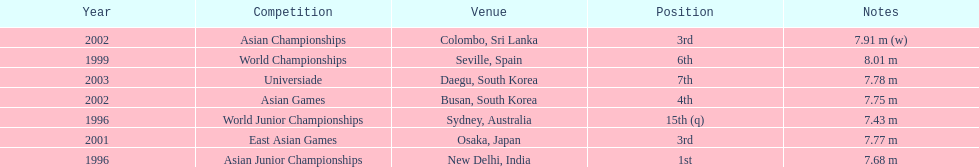In what year was the position of 3rd first achieved? 2001. 